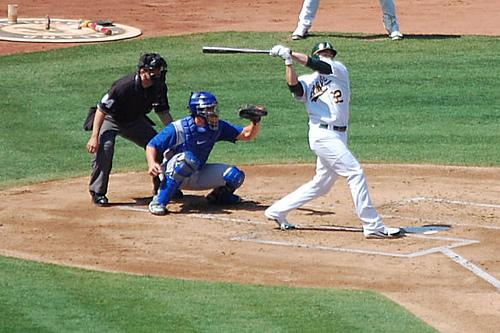Question: why is the catcher behind the hitter?
Choices:
A. That is where he belongs.
B. To guide the pitcher.
C. To catch the ball.
D. To get runner out.
Answer with the letter. Answer: C Question: who is squatting on the ground?
Choices:
A. The umpire.
B. The coach.
C. The artist.
D. The catcher.
Answer with the letter. Answer: D Question: where is this game held?
Choices:
A. College campus.
B. Baseball field.
C. Little League park.
D. High school.
Answer with the letter. Answer: B Question: what is the logo check on the catcher shirt?
Choices:
A. Nike check.
B. Sponser's ad.
C. Shirt brand.
D. Official clothing.
Answer with the letter. Answer: A 